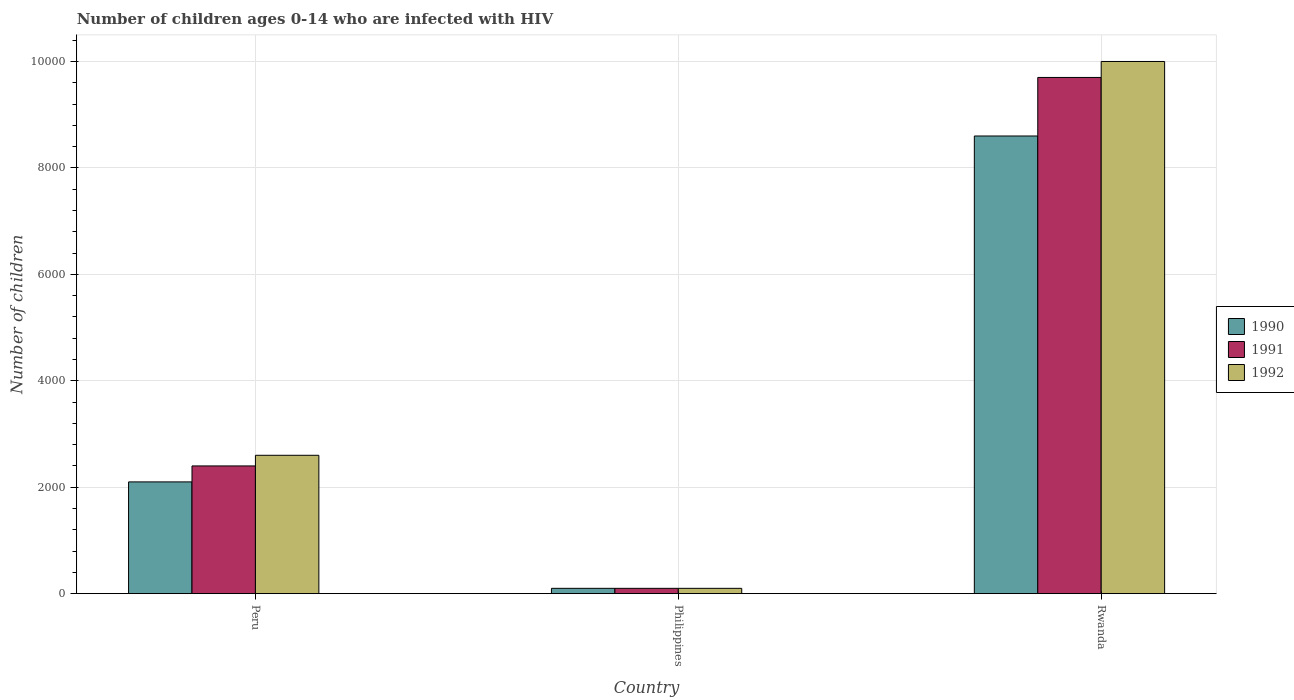How many different coloured bars are there?
Provide a succinct answer. 3. How many groups of bars are there?
Make the answer very short. 3. Are the number of bars per tick equal to the number of legend labels?
Your response must be concise. Yes. How many bars are there on the 1st tick from the right?
Keep it short and to the point. 3. What is the label of the 1st group of bars from the left?
Provide a short and direct response. Peru. In how many cases, is the number of bars for a given country not equal to the number of legend labels?
Ensure brevity in your answer.  0. What is the number of HIV infected children in 1990 in Philippines?
Keep it short and to the point. 100. Across all countries, what is the maximum number of HIV infected children in 1991?
Provide a succinct answer. 9700. Across all countries, what is the minimum number of HIV infected children in 1992?
Give a very brief answer. 100. In which country was the number of HIV infected children in 1990 maximum?
Your response must be concise. Rwanda. What is the total number of HIV infected children in 1990 in the graph?
Keep it short and to the point. 1.08e+04. What is the difference between the number of HIV infected children in 1991 in Peru and that in Rwanda?
Your answer should be compact. -7300. What is the difference between the number of HIV infected children in 1991 in Philippines and the number of HIV infected children in 1990 in Rwanda?
Your answer should be very brief. -8500. What is the average number of HIV infected children in 1991 per country?
Your response must be concise. 4066.67. What is the difference between the number of HIV infected children of/in 1992 and number of HIV infected children of/in 1990 in Rwanda?
Keep it short and to the point. 1400. In how many countries, is the number of HIV infected children in 1991 greater than 7200?
Provide a short and direct response. 1. Is the number of HIV infected children in 1991 in Peru less than that in Rwanda?
Give a very brief answer. Yes. What is the difference between the highest and the second highest number of HIV infected children in 1992?
Make the answer very short. 7400. What is the difference between the highest and the lowest number of HIV infected children in 1991?
Ensure brevity in your answer.  9600. In how many countries, is the number of HIV infected children in 1991 greater than the average number of HIV infected children in 1991 taken over all countries?
Offer a terse response. 1. What does the 2nd bar from the right in Peru represents?
Offer a terse response. 1991. Is it the case that in every country, the sum of the number of HIV infected children in 1991 and number of HIV infected children in 1990 is greater than the number of HIV infected children in 1992?
Make the answer very short. Yes. Are all the bars in the graph horizontal?
Your answer should be compact. No. How many countries are there in the graph?
Your response must be concise. 3. What is the difference between two consecutive major ticks on the Y-axis?
Make the answer very short. 2000. Are the values on the major ticks of Y-axis written in scientific E-notation?
Your response must be concise. No. Where does the legend appear in the graph?
Your answer should be very brief. Center right. How are the legend labels stacked?
Offer a very short reply. Vertical. What is the title of the graph?
Give a very brief answer. Number of children ages 0-14 who are infected with HIV. What is the label or title of the X-axis?
Your answer should be very brief. Country. What is the label or title of the Y-axis?
Give a very brief answer. Number of children. What is the Number of children of 1990 in Peru?
Offer a very short reply. 2100. What is the Number of children in 1991 in Peru?
Your answer should be compact. 2400. What is the Number of children of 1992 in Peru?
Ensure brevity in your answer.  2600. What is the Number of children in 1992 in Philippines?
Make the answer very short. 100. What is the Number of children of 1990 in Rwanda?
Keep it short and to the point. 8600. What is the Number of children of 1991 in Rwanda?
Your answer should be compact. 9700. What is the Number of children in 1992 in Rwanda?
Provide a short and direct response. 10000. Across all countries, what is the maximum Number of children of 1990?
Your answer should be very brief. 8600. Across all countries, what is the maximum Number of children in 1991?
Provide a short and direct response. 9700. Across all countries, what is the minimum Number of children of 1991?
Provide a succinct answer. 100. What is the total Number of children in 1990 in the graph?
Make the answer very short. 1.08e+04. What is the total Number of children in 1991 in the graph?
Your answer should be very brief. 1.22e+04. What is the total Number of children in 1992 in the graph?
Provide a short and direct response. 1.27e+04. What is the difference between the Number of children in 1991 in Peru and that in Philippines?
Provide a succinct answer. 2300. What is the difference between the Number of children in 1992 in Peru and that in Philippines?
Offer a terse response. 2500. What is the difference between the Number of children in 1990 in Peru and that in Rwanda?
Give a very brief answer. -6500. What is the difference between the Number of children in 1991 in Peru and that in Rwanda?
Make the answer very short. -7300. What is the difference between the Number of children in 1992 in Peru and that in Rwanda?
Provide a short and direct response. -7400. What is the difference between the Number of children of 1990 in Philippines and that in Rwanda?
Ensure brevity in your answer.  -8500. What is the difference between the Number of children in 1991 in Philippines and that in Rwanda?
Give a very brief answer. -9600. What is the difference between the Number of children in 1992 in Philippines and that in Rwanda?
Your answer should be compact. -9900. What is the difference between the Number of children in 1990 in Peru and the Number of children in 1991 in Philippines?
Give a very brief answer. 2000. What is the difference between the Number of children in 1991 in Peru and the Number of children in 1992 in Philippines?
Provide a short and direct response. 2300. What is the difference between the Number of children in 1990 in Peru and the Number of children in 1991 in Rwanda?
Provide a short and direct response. -7600. What is the difference between the Number of children in 1990 in Peru and the Number of children in 1992 in Rwanda?
Provide a short and direct response. -7900. What is the difference between the Number of children of 1991 in Peru and the Number of children of 1992 in Rwanda?
Provide a succinct answer. -7600. What is the difference between the Number of children of 1990 in Philippines and the Number of children of 1991 in Rwanda?
Your answer should be compact. -9600. What is the difference between the Number of children of 1990 in Philippines and the Number of children of 1992 in Rwanda?
Your answer should be very brief. -9900. What is the difference between the Number of children in 1991 in Philippines and the Number of children in 1992 in Rwanda?
Offer a terse response. -9900. What is the average Number of children in 1990 per country?
Provide a short and direct response. 3600. What is the average Number of children of 1991 per country?
Your response must be concise. 4066.67. What is the average Number of children of 1992 per country?
Ensure brevity in your answer.  4233.33. What is the difference between the Number of children in 1990 and Number of children in 1991 in Peru?
Ensure brevity in your answer.  -300. What is the difference between the Number of children of 1990 and Number of children of 1992 in Peru?
Provide a short and direct response. -500. What is the difference between the Number of children of 1991 and Number of children of 1992 in Peru?
Provide a short and direct response. -200. What is the difference between the Number of children of 1990 and Number of children of 1991 in Philippines?
Offer a very short reply. 0. What is the difference between the Number of children in 1990 and Number of children in 1992 in Philippines?
Your response must be concise. 0. What is the difference between the Number of children in 1991 and Number of children in 1992 in Philippines?
Offer a terse response. 0. What is the difference between the Number of children in 1990 and Number of children in 1991 in Rwanda?
Keep it short and to the point. -1100. What is the difference between the Number of children of 1990 and Number of children of 1992 in Rwanda?
Offer a terse response. -1400. What is the difference between the Number of children in 1991 and Number of children in 1992 in Rwanda?
Offer a very short reply. -300. What is the ratio of the Number of children in 1990 in Peru to that in Philippines?
Give a very brief answer. 21. What is the ratio of the Number of children in 1990 in Peru to that in Rwanda?
Your answer should be very brief. 0.24. What is the ratio of the Number of children in 1991 in Peru to that in Rwanda?
Offer a very short reply. 0.25. What is the ratio of the Number of children in 1992 in Peru to that in Rwanda?
Your answer should be compact. 0.26. What is the ratio of the Number of children of 1990 in Philippines to that in Rwanda?
Your response must be concise. 0.01. What is the ratio of the Number of children in 1991 in Philippines to that in Rwanda?
Keep it short and to the point. 0.01. What is the ratio of the Number of children of 1992 in Philippines to that in Rwanda?
Offer a terse response. 0.01. What is the difference between the highest and the second highest Number of children of 1990?
Provide a succinct answer. 6500. What is the difference between the highest and the second highest Number of children in 1991?
Ensure brevity in your answer.  7300. What is the difference between the highest and the second highest Number of children in 1992?
Provide a succinct answer. 7400. What is the difference between the highest and the lowest Number of children of 1990?
Your response must be concise. 8500. What is the difference between the highest and the lowest Number of children in 1991?
Make the answer very short. 9600. What is the difference between the highest and the lowest Number of children in 1992?
Ensure brevity in your answer.  9900. 